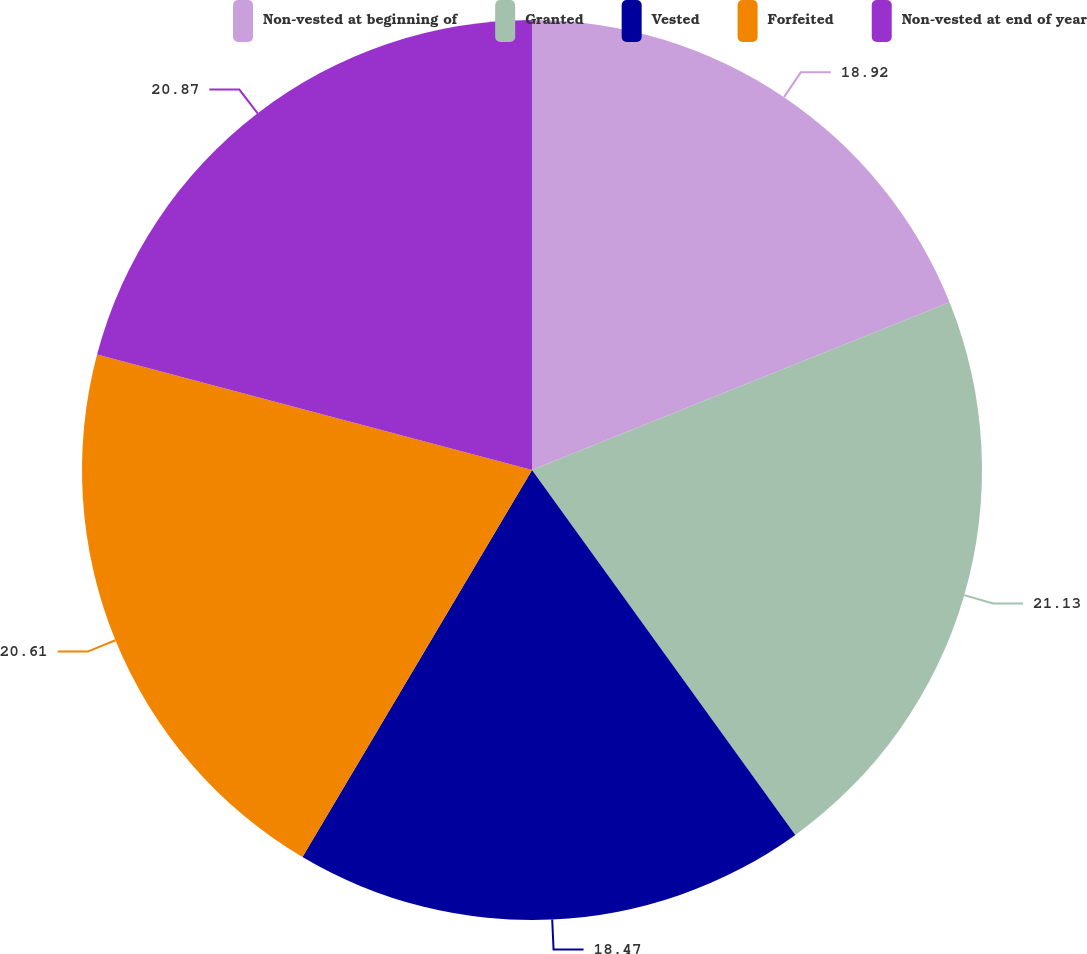Convert chart to OTSL. <chart><loc_0><loc_0><loc_500><loc_500><pie_chart><fcel>Non-vested at beginning of<fcel>Granted<fcel>Vested<fcel>Forfeited<fcel>Non-vested at end of year<nl><fcel>18.92%<fcel>21.13%<fcel>18.47%<fcel>20.61%<fcel>20.87%<nl></chart> 